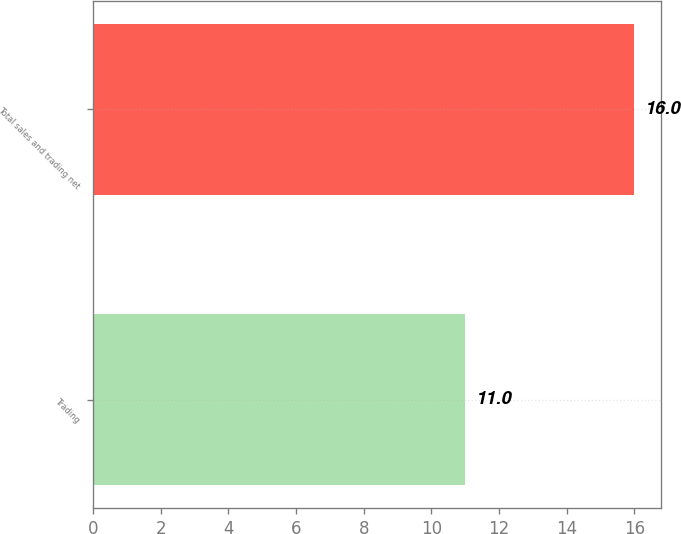Convert chart. <chart><loc_0><loc_0><loc_500><loc_500><bar_chart><fcel>Trading<fcel>Total sales and trading net<nl><fcel>11<fcel>16<nl></chart> 